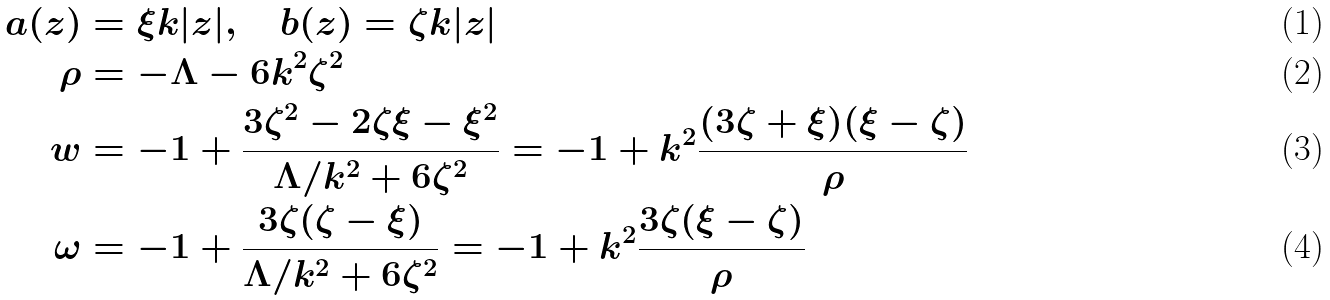<formula> <loc_0><loc_0><loc_500><loc_500>a ( z ) & = \xi k | z | , \quad b ( z ) = \zeta k | z | \\ \rho & = - \Lambda - 6 k ^ { 2 } \zeta ^ { 2 } \\ w & = - 1 + \frac { 3 \zeta ^ { 2 } - 2 \zeta \xi - \xi ^ { 2 } } { \Lambda / k ^ { 2 } + 6 \zeta ^ { 2 } } = - 1 + k ^ { 2 } \frac { ( 3 \zeta + \xi ) ( \xi - \zeta ) } { \rho } \\ \omega & = - 1 + \frac { 3 \zeta ( \zeta - \xi ) } { \Lambda / k ^ { 2 } + 6 \zeta ^ { 2 } } = - 1 + k ^ { 2 } \frac { 3 \zeta ( \xi - \zeta ) } { \rho }</formula> 